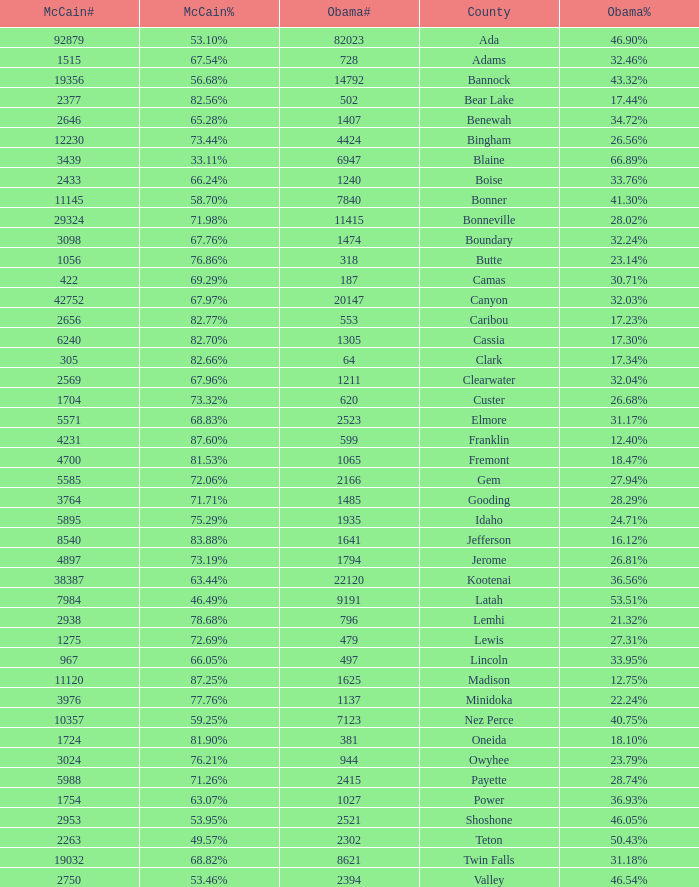What is the McCain vote percentage in Jerome county? 73.19%. 